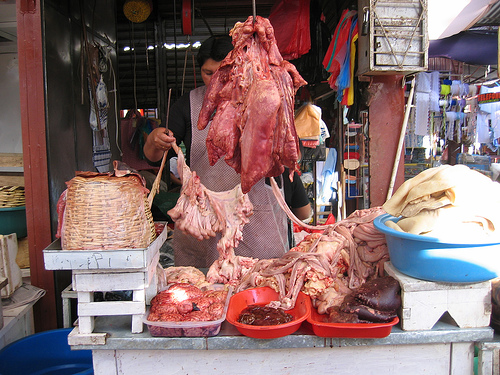<image>
Is the raw meat under the butcher? No. The raw meat is not positioned under the butcher. The vertical relationship between these objects is different. 